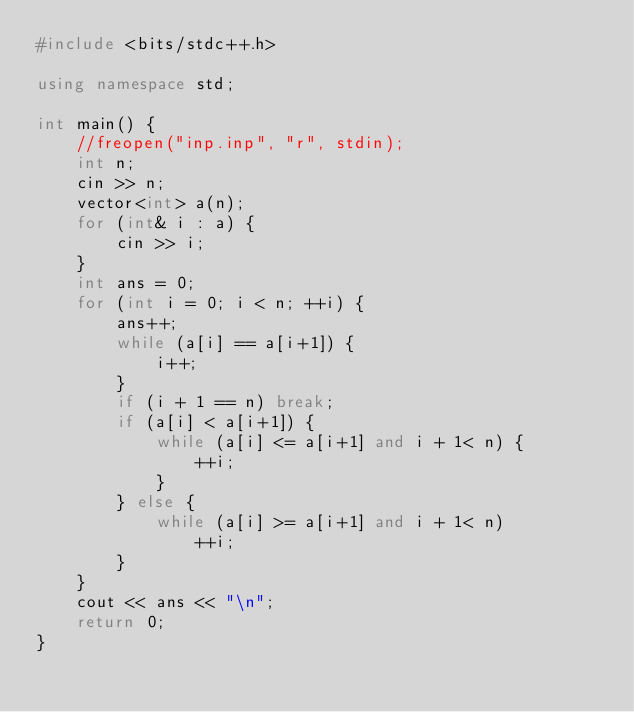Convert code to text. <code><loc_0><loc_0><loc_500><loc_500><_C++_>#include <bits/stdc++.h>

using namespace std;

int main() {
    //freopen("inp.inp", "r", stdin);
    int n;
    cin >> n;
    vector<int> a(n);
    for (int& i : a) {
        cin >> i;
    }
    int ans = 0;
    for (int i = 0; i < n; ++i) {
        ans++;
        while (a[i] == a[i+1]) {
            i++;
        }
        if (i + 1 == n) break;
        if (a[i] < a[i+1]) {
            while (a[i] <= a[i+1] and i + 1< n) {
                ++i;
            }
        } else {
            while (a[i] >= a[i+1] and i + 1< n)
                ++i;
        }
    }
    cout << ans << "\n";
    return 0;
}
</code> 